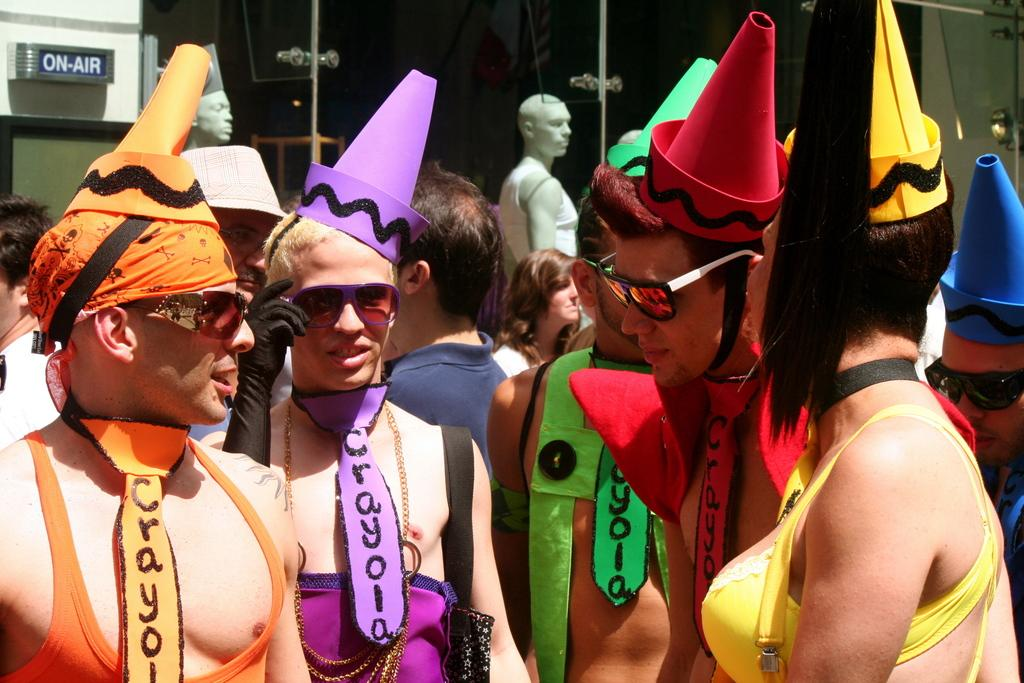What can be seen in the foreground of the picture? There are people wearing different costumes in the foreground of the picture. What is visible in the background of the picture? There are people, mannequins, a glass door, and other objects in the background of the picture. Can you describe the people in the background of the picture? The people in the background of the picture are not as clearly visible as those in the foreground, but they appear to be wearing regular clothing. What type of objects are present in the background of the picture? The other objects in the background of the picture include mannequins and possibly some furniture or decorations. What color is the spot on the wrist of the person in the picture? There is no spot on the wrist of any person in the picture. 